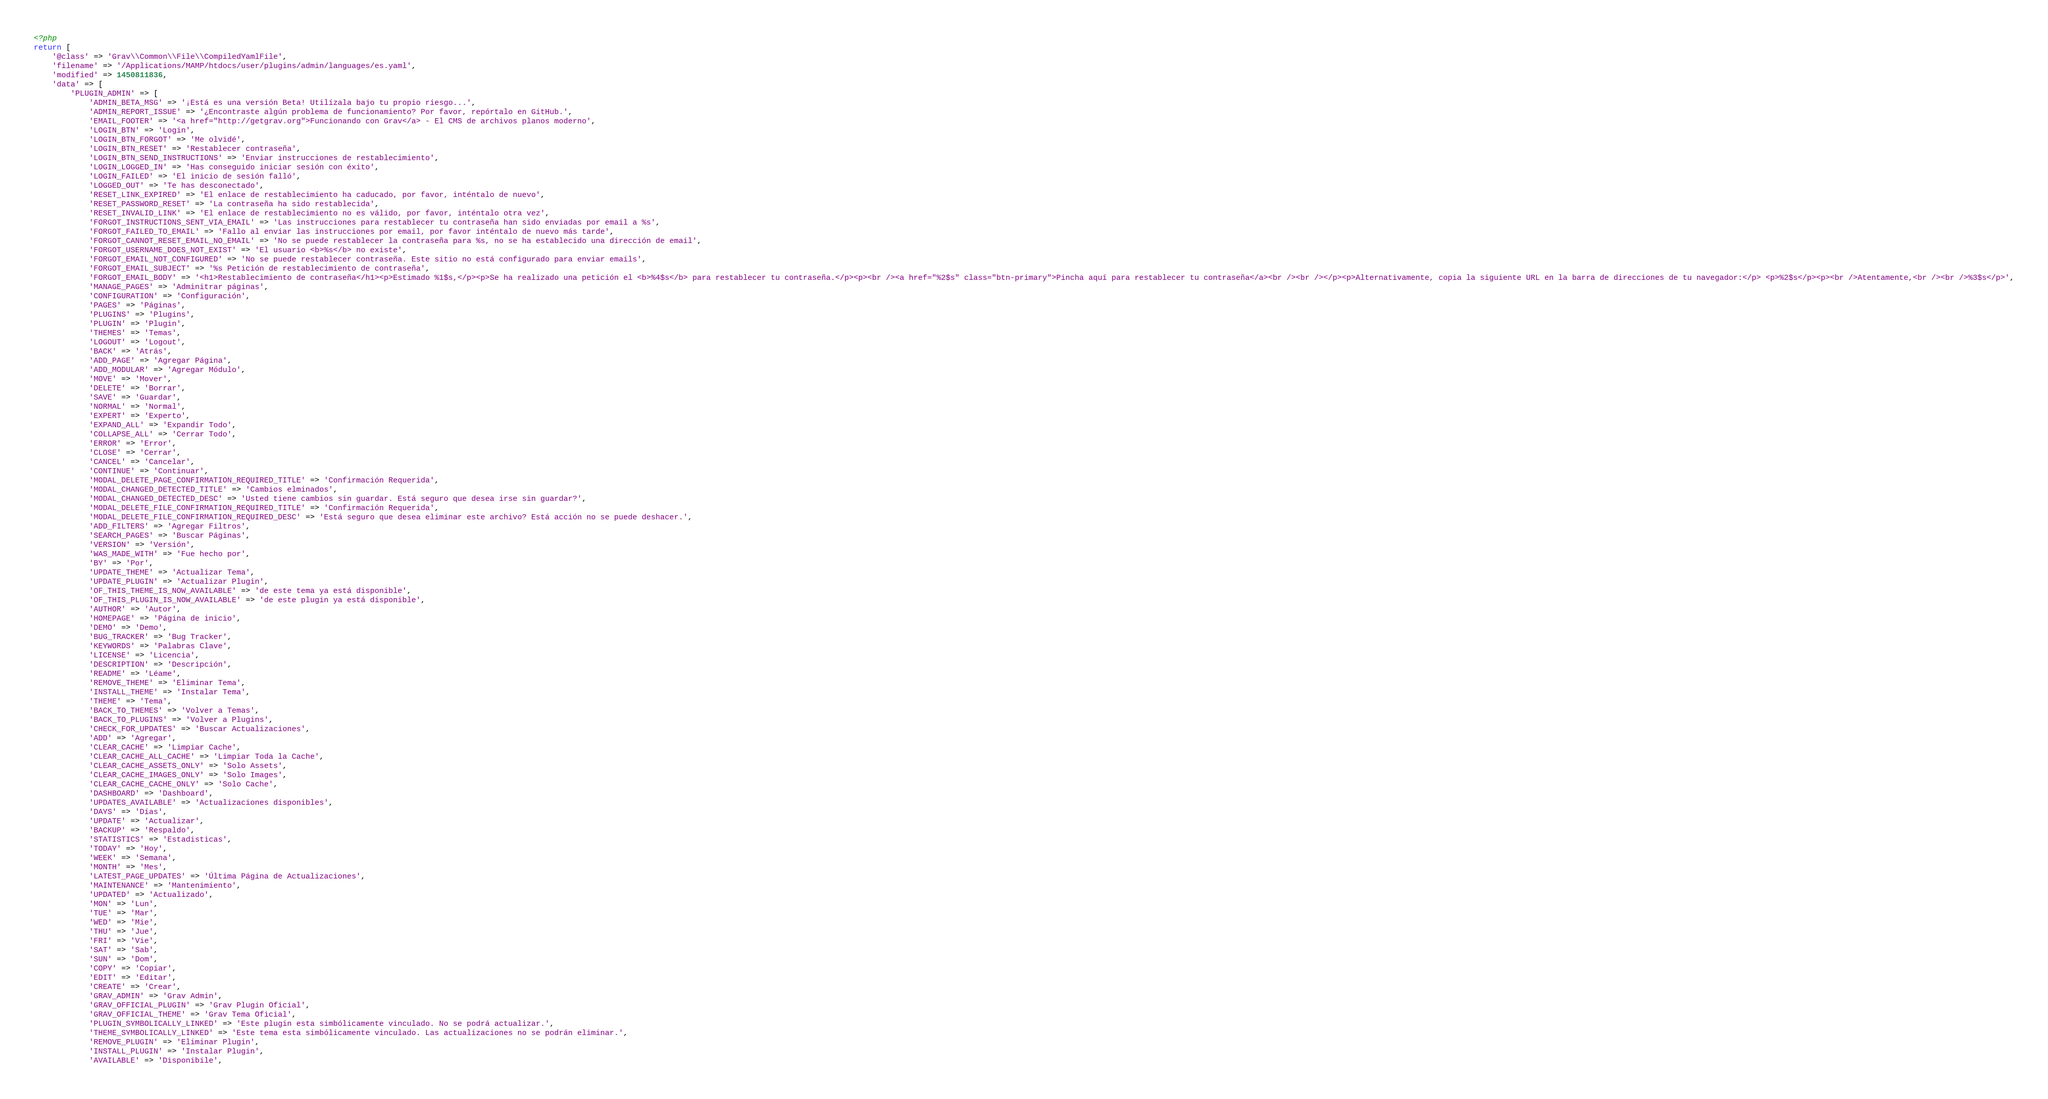<code> <loc_0><loc_0><loc_500><loc_500><_PHP_><?php
return [
    '@class' => 'Grav\\Common\\File\\CompiledYamlFile',
    'filename' => '/Applications/MAMP/htdocs/user/plugins/admin/languages/es.yaml',
    'modified' => 1450811836,
    'data' => [
        'PLUGIN_ADMIN' => [
            'ADMIN_BETA_MSG' => '¡Está es una versión Beta! Utilízala bajo tu propio riesgo...',
            'ADMIN_REPORT_ISSUE' => '¿Encontraste algún problema de funcionamiento? Por favor, repórtalo en GitHub.',
            'EMAIL_FOOTER' => '<a href="http://getgrav.org">Funcionando con Grav</a> - El CMS de archivos planos moderno',
            'LOGIN_BTN' => 'Login',
            'LOGIN_BTN_FORGOT' => 'Me olvidé',
            'LOGIN_BTN_RESET' => 'Restablecer contraseña',
            'LOGIN_BTN_SEND_INSTRUCTIONS' => 'Enviar instrucciones de restablecimiento',
            'LOGIN_LOGGED_IN' => 'Has conseguido iniciar sesión con éxito',
            'LOGIN_FAILED' => 'El inicio de sesión falló',
            'LOGGED_OUT' => 'Te has desconectado',
            'RESET_LINK_EXPIRED' => 'El enlace de restablecimiento ha caducado, por favor, inténtalo de nuevo',
            'RESET_PASSWORD_RESET' => 'La contraseña ha sido restablecida',
            'RESET_INVALID_LINK' => 'El enlace de restablecimiento no es válido, por favor, inténtalo otra vez',
            'FORGOT_INSTRUCTIONS_SENT_VIA_EMAIL' => 'Las instrucciones para restablecer tu contraseña han sido enviadas por email a %s',
            'FORGOT_FAILED_TO_EMAIL' => 'Fallo al enviar las instrucciones por email, por favor inténtalo de nuevo más tarde',
            'FORGOT_CANNOT_RESET_EMAIL_NO_EMAIL' => 'No se puede restablecer la contraseña para %s, no se ha establecido una dirección de email',
            'FORGOT_USERNAME_DOES_NOT_EXIST' => 'El usuario <b>%s</b> no existe',
            'FORGOT_EMAIL_NOT_CONFIGURED' => 'No se puede restablecer contraseña. Este sitio no está configurado para enviar emails',
            'FORGOT_EMAIL_SUBJECT' => '%s Petición de restablecimiento de contraseña',
            'FORGOT_EMAIL_BODY' => '<h1>Restablecimiento de contraseña</h1><p>Estimado %1$s,</p><p>Se ha realizado una petición el <b>%4$s</b> para restablecer tu contraseña.</p><p><br /><a href="%2$s" class="btn-primary">Pincha aquí para restablecer tu contraseña</a><br /><br /></p><p>Alternativamente, copia la siguiente URL en la barra de direcciones de tu navegador:</p> <p>%2$s</p><p><br />Atentamente,<br /><br />%3$s</p>',
            'MANAGE_PAGES' => 'Adminitrar páginas',
            'CONFIGURATION' => 'Configuración',
            'PAGES' => 'Páginas',
            'PLUGINS' => 'Plugins',
            'PLUGIN' => 'Plugin',
            'THEMES' => 'Temas',
            'LOGOUT' => 'Logout',
            'BACK' => 'Atrás',
            'ADD_PAGE' => 'Agregar Página',
            'ADD_MODULAR' => 'Agregar Módulo',
            'MOVE' => 'Mover',
            'DELETE' => 'Borrar',
            'SAVE' => 'Guardar',
            'NORMAL' => 'Normal',
            'EXPERT' => 'Experto',
            'EXPAND_ALL' => 'Expandir Todo',
            'COLLAPSE_ALL' => 'Cerrar Todo',
            'ERROR' => 'Error',
            'CLOSE' => 'Cerrar',
            'CANCEL' => 'Cancelar',
            'CONTINUE' => 'Continuar',
            'MODAL_DELETE_PAGE_CONFIRMATION_REQUIRED_TITLE' => 'Confirmación Requerida',
            'MODAL_CHANGED_DETECTED_TITLE' => 'Cambios elminados',
            'MODAL_CHANGED_DETECTED_DESC' => 'Usted tiene cambios sin guardar. Está seguro que desea irse sin guardar?',
            'MODAL_DELETE_FILE_CONFIRMATION_REQUIRED_TITLE' => 'Confirmación Requerida',
            'MODAL_DELETE_FILE_CONFIRMATION_REQUIRED_DESC' => 'Está seguro que desea eliminar este archivo? Está acción no se puede deshacer.',
            'ADD_FILTERS' => 'Agregar Filtros',
            'SEARCH_PAGES' => 'Buscar Páginas',
            'VERSION' => 'Versión',
            'WAS_MADE_WITH' => 'Fue hecho por',
            'BY' => 'Por',
            'UPDATE_THEME' => 'Actualizar Tema',
            'UPDATE_PLUGIN' => 'Actualizar Plugin',
            'OF_THIS_THEME_IS_NOW_AVAILABLE' => 'de este tema ya está disponible',
            'OF_THIS_PLUGIN_IS_NOW_AVAILABLE' => 'de este plugin ya está disponible',
            'AUTHOR' => 'Autor',
            'HOMEPAGE' => 'Página de inicio',
            'DEMO' => 'Demo',
            'BUG_TRACKER' => 'Bug Tracker',
            'KEYWORDS' => 'Palabras Clave',
            'LICENSE' => 'Licencia',
            'DESCRIPTION' => 'Descripción',
            'README' => 'Léame',
            'REMOVE_THEME' => 'Eliminar Tema',
            'INSTALL_THEME' => 'Instalar Tema',
            'THEME' => 'Tema',
            'BACK_TO_THEMES' => 'Volver a Temas',
            'BACK_TO_PLUGINS' => 'Volver a Plugins',
            'CHECK_FOR_UPDATES' => 'Buscar Actualizaciones',
            'ADD' => 'Agregar',
            'CLEAR_CACHE' => 'Limpiar Cache',
            'CLEAR_CACHE_ALL_CACHE' => 'Limpiar Toda la Cache',
            'CLEAR_CACHE_ASSETS_ONLY' => 'Solo Assets',
            'CLEAR_CACHE_IMAGES_ONLY' => 'Solo Images',
            'CLEAR_CACHE_CACHE_ONLY' => 'Solo Cache',
            'DASHBOARD' => 'Dashboard',
            'UPDATES_AVAILABLE' => 'Actualizaciones disponibles',
            'DAYS' => 'Días',
            'UPDATE' => 'Actualizar',
            'BACKUP' => 'Respaldo',
            'STATISTICS' => 'Estadisticas',
            'TODAY' => 'Hoy',
            'WEEK' => 'Semana',
            'MONTH' => 'Mes',
            'LATEST_PAGE_UPDATES' => 'Última Página de Actualizaciones',
            'MAINTENANCE' => 'Mantenimiento',
            'UPDATED' => 'Actualizado',
            'MON' => 'Lun',
            'TUE' => 'Mar',
            'WED' => 'Mie',
            'THU' => 'Jue',
            'FRI' => 'Vie',
            'SAT' => 'Sab',
            'SUN' => 'Dom',
            'COPY' => 'Copiar',
            'EDIT' => 'Editar',
            'CREATE' => 'Crear',
            'GRAV_ADMIN' => 'Grav Admin',
            'GRAV_OFFICIAL_PLUGIN' => 'Grav Plugin Oficial',
            'GRAV_OFFICIAL_THEME' => 'Grav Tema Oficial',
            'PLUGIN_SYMBOLICALLY_LINKED' => 'Este plugin esta simbólicamente vinculado. No se podrá actualizar.',
            'THEME_SYMBOLICALLY_LINKED' => 'Este tema esta simbólicamente vinculado. Las actualizaciones no se podrán eliminar.',
            'REMOVE_PLUGIN' => 'Eliminar Plugin',
            'INSTALL_PLUGIN' => 'Instalar Plugin',
            'AVAILABLE' => 'Disponibile',</code> 